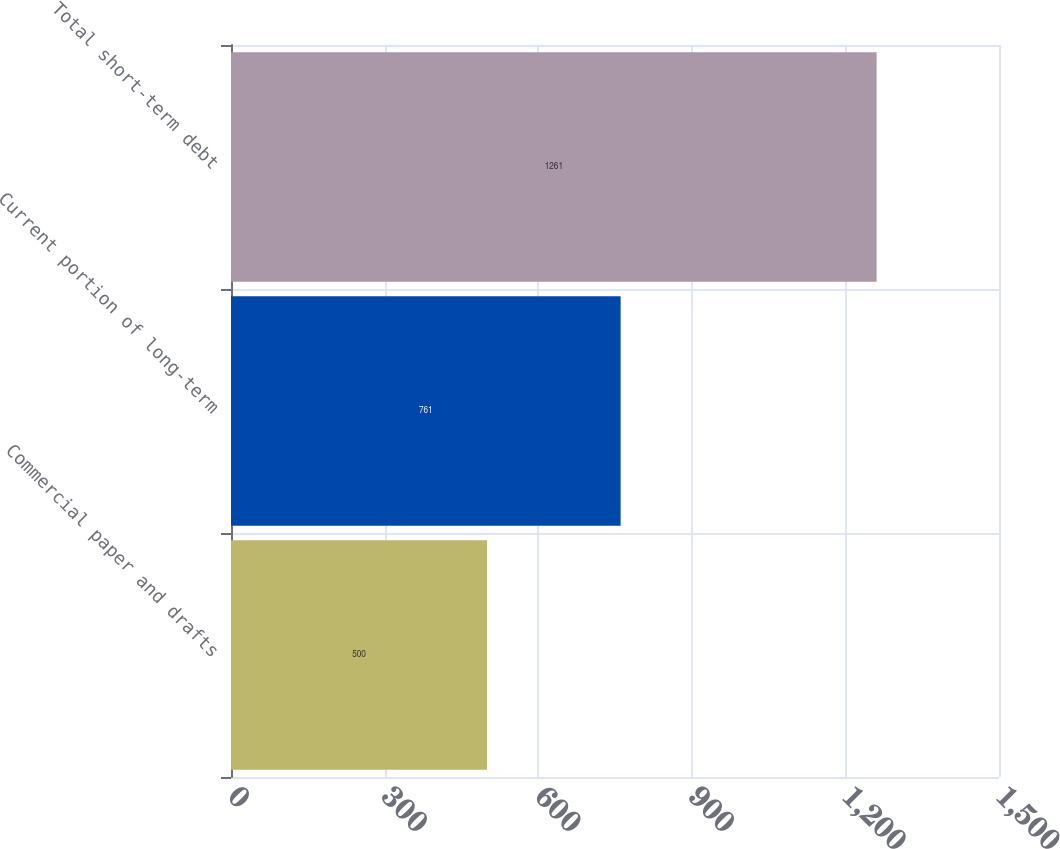<chart> <loc_0><loc_0><loc_500><loc_500><bar_chart><fcel>Commercial paper and drafts<fcel>Current portion of long-term<fcel>Total short-term debt<nl><fcel>500<fcel>761<fcel>1261<nl></chart> 